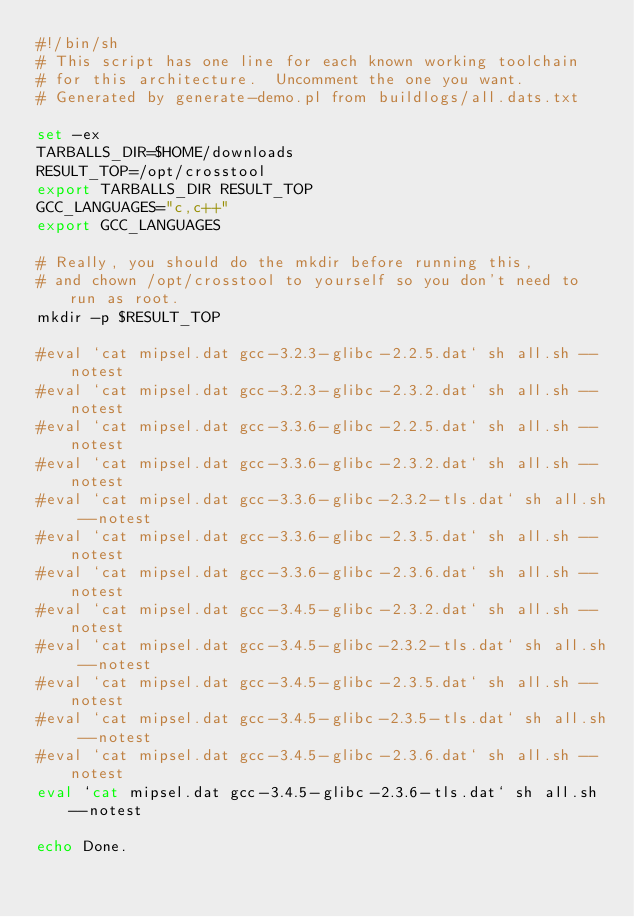<code> <loc_0><loc_0><loc_500><loc_500><_Bash_>#!/bin/sh
# This script has one line for each known working toolchain
# for this architecture.  Uncomment the one you want.
# Generated by generate-demo.pl from buildlogs/all.dats.txt

set -ex
TARBALLS_DIR=$HOME/downloads
RESULT_TOP=/opt/crosstool
export TARBALLS_DIR RESULT_TOP
GCC_LANGUAGES="c,c++"
export GCC_LANGUAGES

# Really, you should do the mkdir before running this,
# and chown /opt/crosstool to yourself so you don't need to run as root.
mkdir -p $RESULT_TOP

#eval `cat mipsel.dat gcc-3.2.3-glibc-2.2.5.dat` sh all.sh --notest
#eval `cat mipsel.dat gcc-3.2.3-glibc-2.3.2.dat` sh all.sh --notest
#eval `cat mipsel.dat gcc-3.3.6-glibc-2.2.5.dat` sh all.sh --notest
#eval `cat mipsel.dat gcc-3.3.6-glibc-2.3.2.dat` sh all.sh --notest
#eval `cat mipsel.dat gcc-3.3.6-glibc-2.3.2-tls.dat` sh all.sh --notest
#eval `cat mipsel.dat gcc-3.3.6-glibc-2.3.5.dat` sh all.sh --notest
#eval `cat mipsel.dat gcc-3.3.6-glibc-2.3.6.dat` sh all.sh --notest
#eval `cat mipsel.dat gcc-3.4.5-glibc-2.3.2.dat` sh all.sh --notest
#eval `cat mipsel.dat gcc-3.4.5-glibc-2.3.2-tls.dat` sh all.sh --notest
#eval `cat mipsel.dat gcc-3.4.5-glibc-2.3.5.dat` sh all.sh --notest
#eval `cat mipsel.dat gcc-3.4.5-glibc-2.3.5-tls.dat` sh all.sh --notest
#eval `cat mipsel.dat gcc-3.4.5-glibc-2.3.6.dat` sh all.sh --notest
eval `cat mipsel.dat gcc-3.4.5-glibc-2.3.6-tls.dat` sh all.sh --notest

echo Done.
</code> 